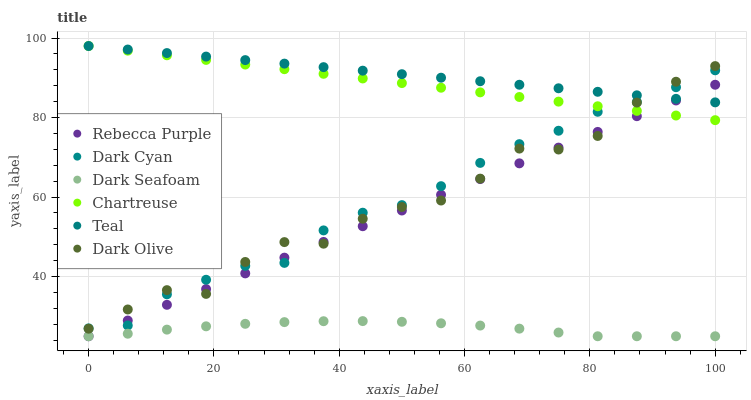Does Dark Seafoam have the minimum area under the curve?
Answer yes or no. Yes. Does Teal have the maximum area under the curve?
Answer yes or no. Yes. Does Chartreuse have the minimum area under the curve?
Answer yes or no. No. Does Chartreuse have the maximum area under the curve?
Answer yes or no. No. Is Rebecca Purple the smoothest?
Answer yes or no. Yes. Is Dark Olive the roughest?
Answer yes or no. Yes. Is Chartreuse the smoothest?
Answer yes or no. No. Is Chartreuse the roughest?
Answer yes or no. No. Does Dark Seafoam have the lowest value?
Answer yes or no. Yes. Does Chartreuse have the lowest value?
Answer yes or no. No. Does Teal have the highest value?
Answer yes or no. Yes. Does Dark Seafoam have the highest value?
Answer yes or no. No. Is Dark Seafoam less than Dark Olive?
Answer yes or no. Yes. Is Teal greater than Dark Seafoam?
Answer yes or no. Yes. Does Chartreuse intersect Teal?
Answer yes or no. Yes. Is Chartreuse less than Teal?
Answer yes or no. No. Is Chartreuse greater than Teal?
Answer yes or no. No. Does Dark Seafoam intersect Dark Olive?
Answer yes or no. No. 